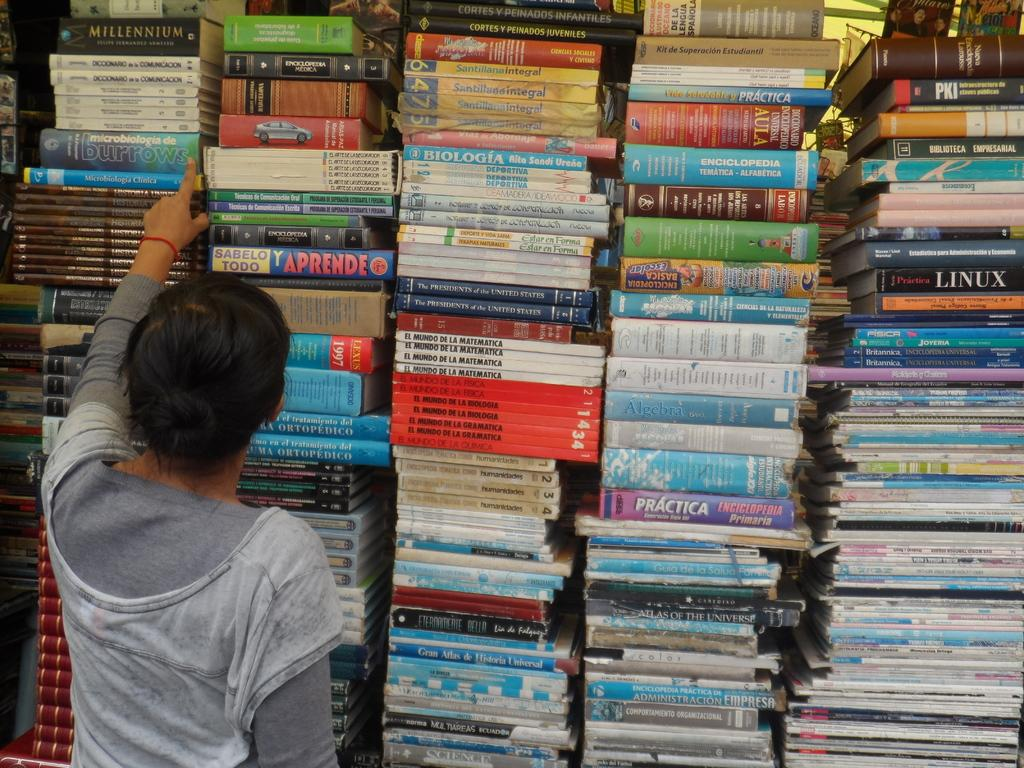<image>
Render a clear and concise summary of the photo. a book that is called Linux sits on a stack 